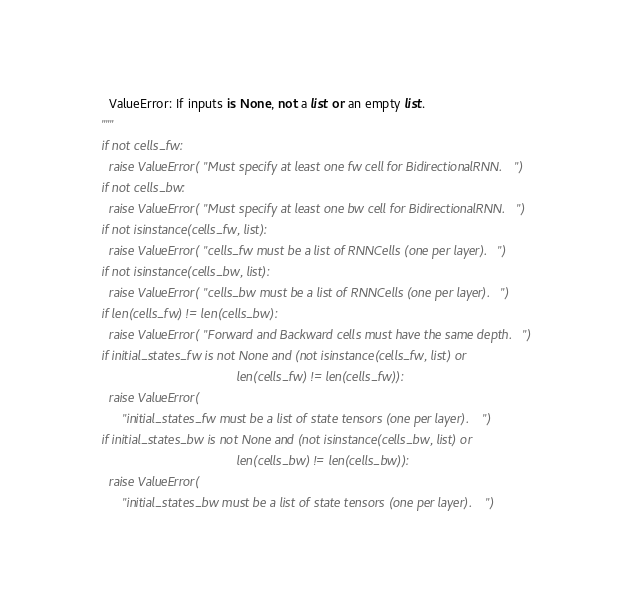<code> <loc_0><loc_0><loc_500><loc_500><_Python_>    ValueError: If inputs is None, not a list or an empty list.
  """
  if not cells_fw:
    raise ValueError("Must specify at least one fw cell for BidirectionalRNN.")
  if not cells_bw:
    raise ValueError("Must specify at least one bw cell for BidirectionalRNN.")
  if not isinstance(cells_fw, list):
    raise ValueError("cells_fw must be a list of RNNCells (one per layer).")
  if not isinstance(cells_bw, list):
    raise ValueError("cells_bw must be a list of RNNCells (one per layer).")
  if len(cells_fw) != len(cells_bw):
    raise ValueError("Forward and Backward cells must have the same depth.")
  if initial_states_fw is not None and (not isinstance(cells_fw, list) or
                                        len(cells_fw) != len(cells_fw)):
    raise ValueError(
        "initial_states_fw must be a list of state tensors (one per layer).")
  if initial_states_bw is not None and (not isinstance(cells_bw, list) or
                                        len(cells_bw) != len(cells_bw)):
    raise ValueError(
        "initial_states_bw must be a list of state tensors (one per layer).")</code> 